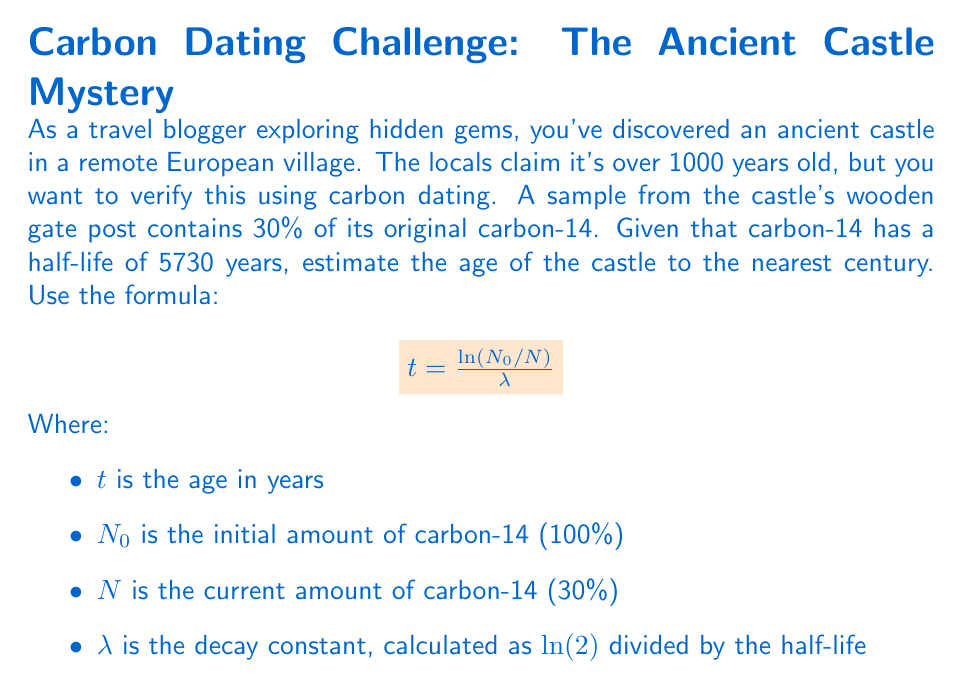Help me with this question. Let's approach this problem step-by-step:

1) First, we need to calculate the decay constant $\lambda$:
   $$\lambda = \frac{\ln(2)}{5730} \approx 0.000121$$

2) Now, we can plug the values into the formula:
   $$t = \frac{\ln(N_0/N)}{\lambda}$$

   Where:
   $N_0 = 100\%$ (initial amount)
   $N = 30\%$ (current amount)

3) Substituting these values:
   $$t = \frac{\ln(100/30)}{0.000121}$$

4) Simplify inside the logarithm:
   $$t = \frac{\ln(3.33333...)}{0.000121}$$

5) Calculate the natural logarithm:
   $$t = \frac{1.20397...}{0.000121}$$

6) Divide:
   $$t \approx 9950.99$$

7) Rounding to the nearest century (100 years):
   $$t \approx 10000 \text{ years}$$

Therefore, the estimated age of the castle is approximately 10,000 years.
Answer: 10,000 years 